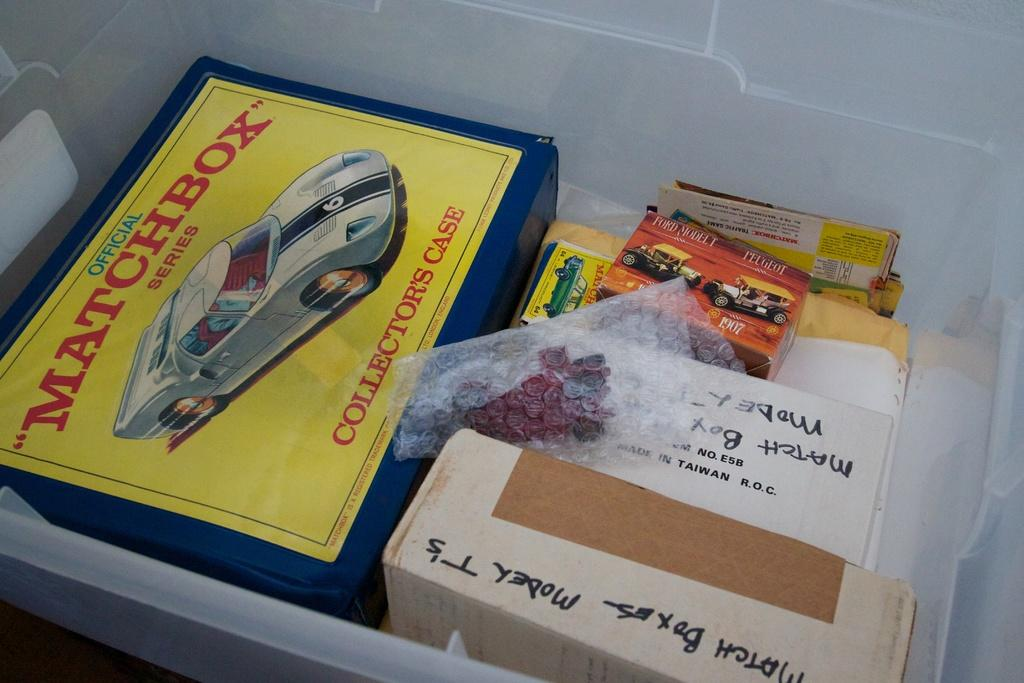What type of objects can be seen in the image? There are cartons in the image. Can you describe the placement of an object in the image? There is a cover placed in a box in the image. How many goldfish can be seen swimming under the bridge in the image? There is no bridge or goldfish present in the image. 